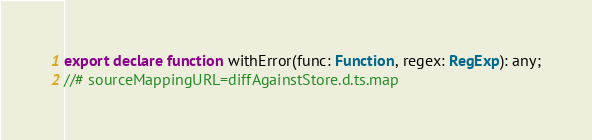<code> <loc_0><loc_0><loc_500><loc_500><_TypeScript_>export declare function withError(func: Function, regex: RegExp): any;
//# sourceMappingURL=diffAgainstStore.d.ts.map</code> 